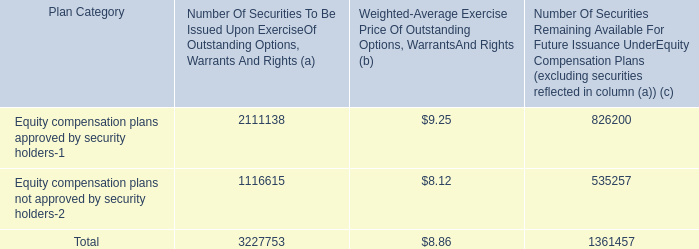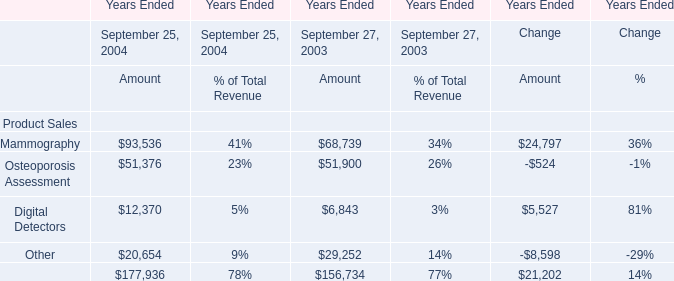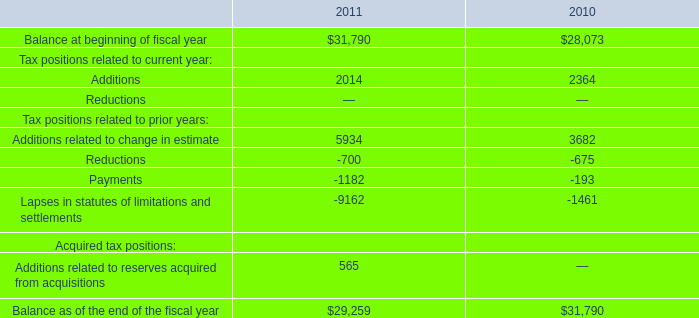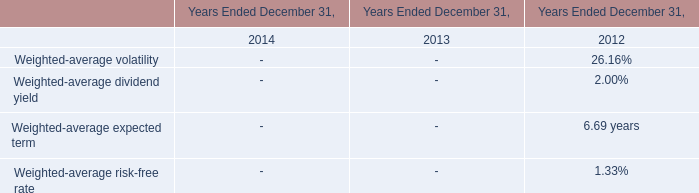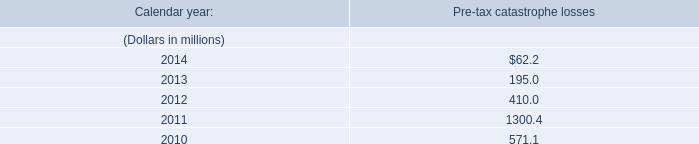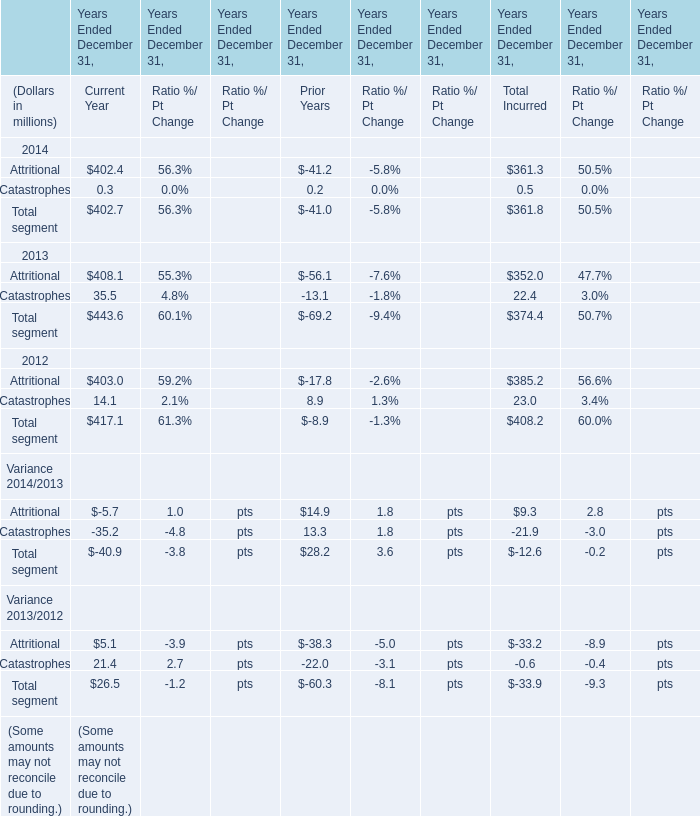What is the growing rate of Osteoporosis Assessment in the years with the least Mammography ？ 
Computations: ((51376 - 51900) / 51900)
Answer: -0.0101. 